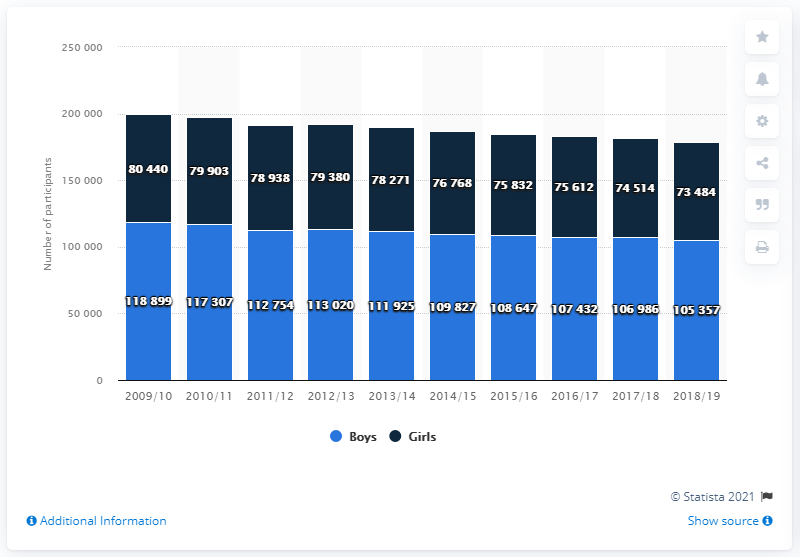Highlight a few significant elements in this photo. The year with the highest participant count was 2009/2010. The average participation rate for girls during the years 2009/10-2011/12 was 79,760.3333 and... In the 2018/2019 school year, 105,357 boys participated in high school sports. 